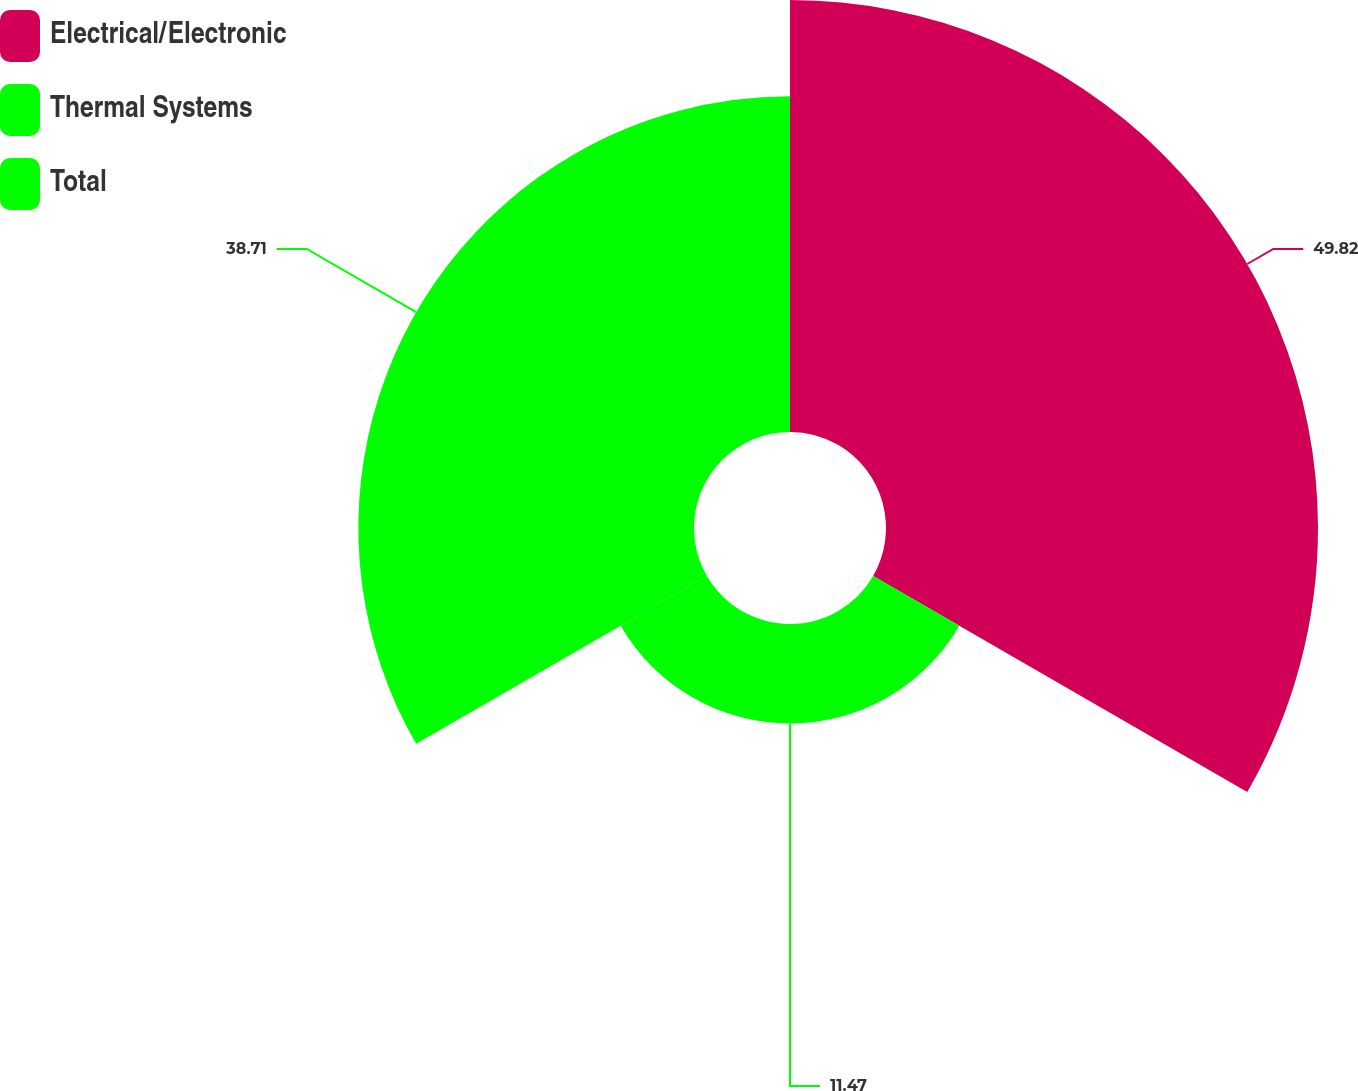Convert chart to OTSL. <chart><loc_0><loc_0><loc_500><loc_500><pie_chart><fcel>Electrical/Electronic<fcel>Thermal Systems<fcel>Total<nl><fcel>49.82%<fcel>11.47%<fcel>38.71%<nl></chart> 